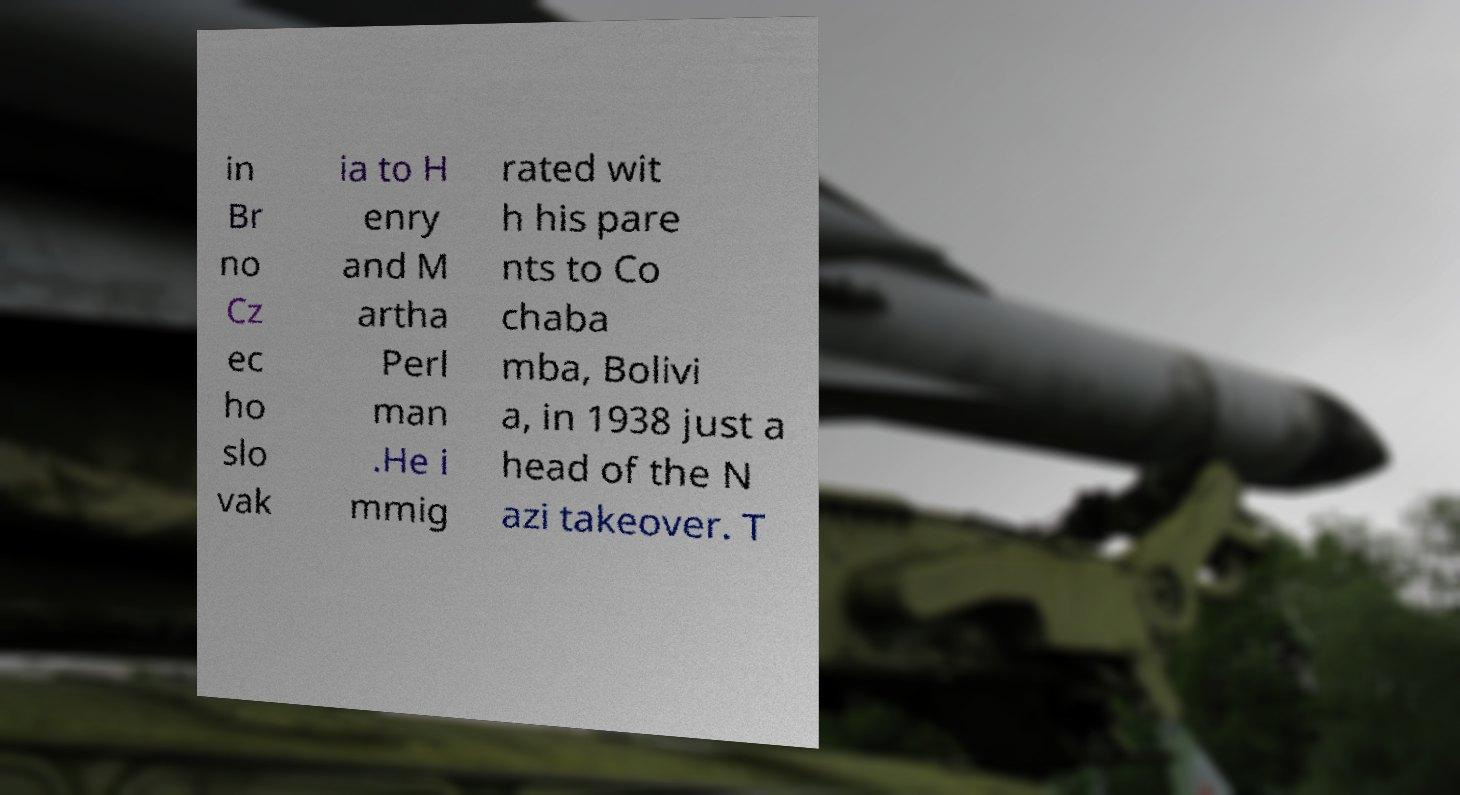Could you assist in decoding the text presented in this image and type it out clearly? in Br no Cz ec ho slo vak ia to H enry and M artha Perl man .He i mmig rated wit h his pare nts to Co chaba mba, Bolivi a, in 1938 just a head of the N azi takeover. T 